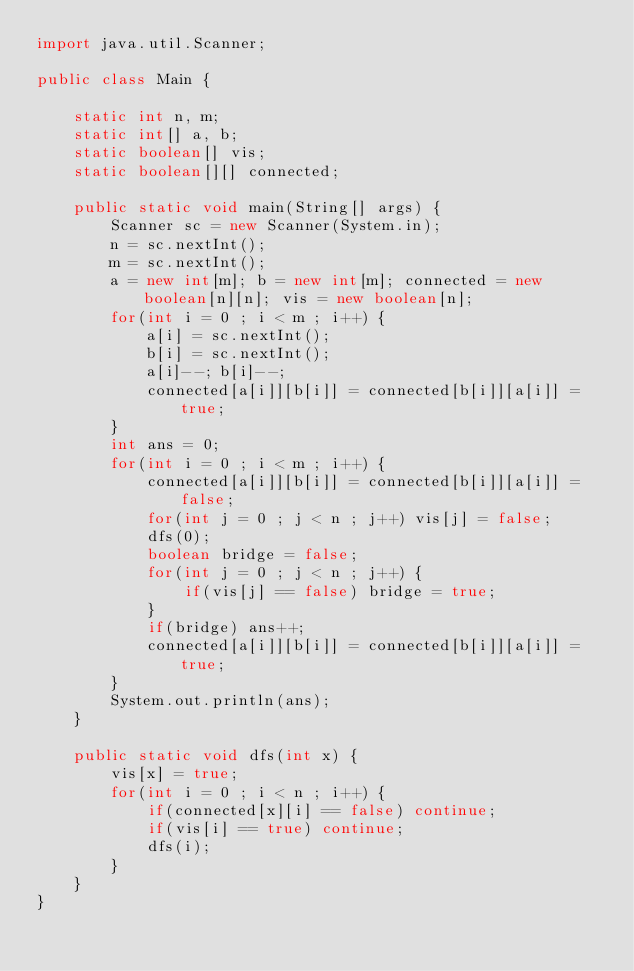<code> <loc_0><loc_0><loc_500><loc_500><_Java_>import java.util.Scanner;

public class Main {

	static int n, m;
	static int[] a, b;
	static boolean[] vis;
	static boolean[][] connected;

	public static void main(String[] args) {
		Scanner sc = new Scanner(System.in);
		n = sc.nextInt();
		m = sc.nextInt();
		a = new int[m]; b = new int[m]; connected = new boolean[n][n]; vis = new boolean[n];
		for(int i = 0 ; i < m ; i++) {
			a[i] = sc.nextInt();
			b[i] = sc.nextInt();
			a[i]--; b[i]--;
			connected[a[i]][b[i]] = connected[b[i]][a[i]] = true;
		}
		int ans = 0;
		for(int i = 0 ; i < m ; i++) {
			connected[a[i]][b[i]] = connected[b[i]][a[i]] = false;
			for(int j = 0 ; j < n ; j++) vis[j] = false;
			dfs(0);
			boolean bridge = false;
			for(int j = 0 ; j < n ; j++) {
				if(vis[j] == false) bridge = true;
			}
			if(bridge) ans++;
			connected[a[i]][b[i]] = connected[b[i]][a[i]] = true;
		}
		System.out.println(ans);
	}

	public static void dfs(int x) {
		vis[x] = true;
		for(int i = 0 ; i < n ; i++) {
			if(connected[x][i] == false) continue;
			if(vis[i] == true) continue;
			dfs(i);
		}
	}
}
</code> 